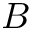<formula> <loc_0><loc_0><loc_500><loc_500>B</formula> 